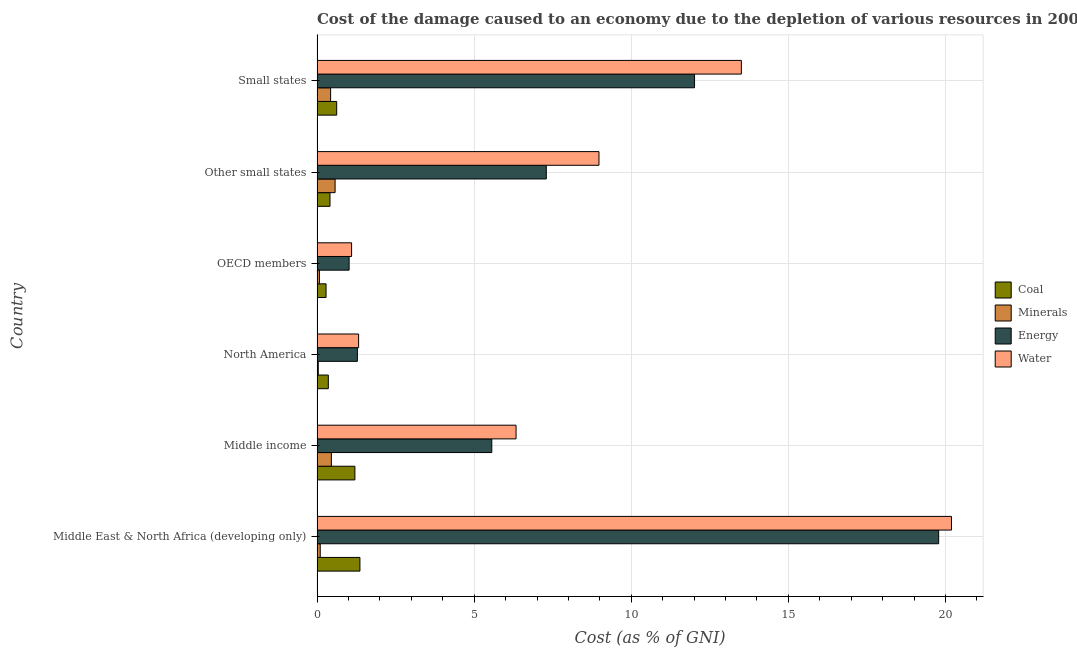Are the number of bars on each tick of the Y-axis equal?
Offer a very short reply. Yes. What is the label of the 2nd group of bars from the top?
Make the answer very short. Other small states. In how many cases, is the number of bars for a given country not equal to the number of legend labels?
Your response must be concise. 0. What is the cost of damage due to depletion of coal in Middle income?
Offer a very short reply. 1.2. Across all countries, what is the maximum cost of damage due to depletion of coal?
Your answer should be very brief. 1.36. Across all countries, what is the minimum cost of damage due to depletion of coal?
Make the answer very short. 0.29. In which country was the cost of damage due to depletion of energy maximum?
Make the answer very short. Middle East & North Africa (developing only). In which country was the cost of damage due to depletion of coal minimum?
Your answer should be very brief. OECD members. What is the total cost of damage due to depletion of coal in the graph?
Keep it short and to the point. 4.25. What is the difference between the cost of damage due to depletion of minerals in Middle East & North Africa (developing only) and that in Small states?
Give a very brief answer. -0.33. What is the difference between the cost of damage due to depletion of minerals in Small states and the cost of damage due to depletion of energy in North America?
Offer a very short reply. -0.85. What is the average cost of damage due to depletion of coal per country?
Keep it short and to the point. 0.71. What is the difference between the cost of damage due to depletion of minerals and cost of damage due to depletion of coal in Other small states?
Your answer should be very brief. 0.16. What is the ratio of the cost of damage due to depletion of coal in OECD members to that in Other small states?
Make the answer very short. 0.69. What is the difference between the highest and the second highest cost of damage due to depletion of water?
Your answer should be compact. 6.69. What is the difference between the highest and the lowest cost of damage due to depletion of minerals?
Ensure brevity in your answer.  0.53. In how many countries, is the cost of damage due to depletion of coal greater than the average cost of damage due to depletion of coal taken over all countries?
Offer a very short reply. 2. Is the sum of the cost of damage due to depletion of energy in North America and Other small states greater than the maximum cost of damage due to depletion of coal across all countries?
Provide a succinct answer. Yes. Is it the case that in every country, the sum of the cost of damage due to depletion of minerals and cost of damage due to depletion of energy is greater than the sum of cost of damage due to depletion of water and cost of damage due to depletion of coal?
Your answer should be very brief. No. What does the 4th bar from the top in Middle income represents?
Offer a terse response. Coal. What does the 1st bar from the bottom in OECD members represents?
Offer a terse response. Coal. How many bars are there?
Your answer should be very brief. 24. What is the difference between two consecutive major ticks on the X-axis?
Your answer should be compact. 5. Does the graph contain grids?
Offer a terse response. Yes. Where does the legend appear in the graph?
Give a very brief answer. Center right. How many legend labels are there?
Your answer should be very brief. 4. What is the title of the graph?
Offer a terse response. Cost of the damage caused to an economy due to the depletion of various resources in 2005 . What is the label or title of the X-axis?
Keep it short and to the point. Cost (as % of GNI). What is the Cost (as % of GNI) of Coal in Middle East & North Africa (developing only)?
Your answer should be very brief. 1.36. What is the Cost (as % of GNI) in Minerals in Middle East & North Africa (developing only)?
Your answer should be compact. 0.1. What is the Cost (as % of GNI) of Energy in Middle East & North Africa (developing only)?
Give a very brief answer. 19.78. What is the Cost (as % of GNI) of Water in Middle East & North Africa (developing only)?
Provide a short and direct response. 20.19. What is the Cost (as % of GNI) in Coal in Middle income?
Provide a short and direct response. 1.2. What is the Cost (as % of GNI) in Minerals in Middle income?
Make the answer very short. 0.46. What is the Cost (as % of GNI) of Energy in Middle income?
Offer a very short reply. 5.56. What is the Cost (as % of GNI) in Water in Middle income?
Your answer should be very brief. 6.33. What is the Cost (as % of GNI) in Coal in North America?
Provide a succinct answer. 0.36. What is the Cost (as % of GNI) in Minerals in North America?
Keep it short and to the point. 0.04. What is the Cost (as % of GNI) of Energy in North America?
Give a very brief answer. 1.28. What is the Cost (as % of GNI) in Water in North America?
Provide a succinct answer. 1.32. What is the Cost (as % of GNI) of Coal in OECD members?
Your answer should be very brief. 0.29. What is the Cost (as % of GNI) of Minerals in OECD members?
Ensure brevity in your answer.  0.08. What is the Cost (as % of GNI) of Energy in OECD members?
Offer a very short reply. 1.02. What is the Cost (as % of GNI) in Water in OECD members?
Offer a terse response. 1.1. What is the Cost (as % of GNI) of Coal in Other small states?
Your answer should be compact. 0.41. What is the Cost (as % of GNI) of Minerals in Other small states?
Keep it short and to the point. 0.57. What is the Cost (as % of GNI) in Energy in Other small states?
Make the answer very short. 7.3. What is the Cost (as % of GNI) in Water in Other small states?
Make the answer very short. 8.97. What is the Cost (as % of GNI) in Coal in Small states?
Make the answer very short. 0.63. What is the Cost (as % of GNI) of Minerals in Small states?
Ensure brevity in your answer.  0.43. What is the Cost (as % of GNI) in Energy in Small states?
Offer a very short reply. 12.01. What is the Cost (as % of GNI) in Water in Small states?
Provide a succinct answer. 13.5. Across all countries, what is the maximum Cost (as % of GNI) of Coal?
Your response must be concise. 1.36. Across all countries, what is the maximum Cost (as % of GNI) in Minerals?
Provide a short and direct response. 0.57. Across all countries, what is the maximum Cost (as % of GNI) in Energy?
Provide a succinct answer. 19.78. Across all countries, what is the maximum Cost (as % of GNI) of Water?
Keep it short and to the point. 20.19. Across all countries, what is the minimum Cost (as % of GNI) in Coal?
Keep it short and to the point. 0.29. Across all countries, what is the minimum Cost (as % of GNI) in Minerals?
Your answer should be very brief. 0.04. Across all countries, what is the minimum Cost (as % of GNI) of Energy?
Offer a terse response. 1.02. Across all countries, what is the minimum Cost (as % of GNI) in Water?
Your answer should be compact. 1.1. What is the total Cost (as % of GNI) of Coal in the graph?
Your response must be concise. 4.25. What is the total Cost (as % of GNI) of Minerals in the graph?
Offer a terse response. 1.68. What is the total Cost (as % of GNI) of Energy in the graph?
Make the answer very short. 46.96. What is the total Cost (as % of GNI) in Water in the graph?
Provide a short and direct response. 51.42. What is the difference between the Cost (as % of GNI) of Coal in Middle East & North Africa (developing only) and that in Middle income?
Your response must be concise. 0.16. What is the difference between the Cost (as % of GNI) in Minerals in Middle East & North Africa (developing only) and that in Middle income?
Make the answer very short. -0.35. What is the difference between the Cost (as % of GNI) in Energy in Middle East & North Africa (developing only) and that in Middle income?
Give a very brief answer. 14.22. What is the difference between the Cost (as % of GNI) of Water in Middle East & North Africa (developing only) and that in Middle income?
Provide a short and direct response. 13.86. What is the difference between the Cost (as % of GNI) of Coal in Middle East & North Africa (developing only) and that in North America?
Provide a succinct answer. 1.01. What is the difference between the Cost (as % of GNI) in Minerals in Middle East & North Africa (developing only) and that in North America?
Offer a very short reply. 0.06. What is the difference between the Cost (as % of GNI) in Energy in Middle East & North Africa (developing only) and that in North America?
Your answer should be compact. 18.5. What is the difference between the Cost (as % of GNI) in Water in Middle East & North Africa (developing only) and that in North America?
Provide a short and direct response. 18.87. What is the difference between the Cost (as % of GNI) in Coal in Middle East & North Africa (developing only) and that in OECD members?
Keep it short and to the point. 1.08. What is the difference between the Cost (as % of GNI) of Minerals in Middle East & North Africa (developing only) and that in OECD members?
Keep it short and to the point. 0.03. What is the difference between the Cost (as % of GNI) of Energy in Middle East & North Africa (developing only) and that in OECD members?
Your answer should be very brief. 18.76. What is the difference between the Cost (as % of GNI) of Water in Middle East & North Africa (developing only) and that in OECD members?
Your answer should be compact. 19.09. What is the difference between the Cost (as % of GNI) in Coal in Middle East & North Africa (developing only) and that in Other small states?
Keep it short and to the point. 0.95. What is the difference between the Cost (as % of GNI) in Minerals in Middle East & North Africa (developing only) and that in Other small states?
Provide a short and direct response. -0.47. What is the difference between the Cost (as % of GNI) in Energy in Middle East & North Africa (developing only) and that in Other small states?
Make the answer very short. 12.49. What is the difference between the Cost (as % of GNI) in Water in Middle East & North Africa (developing only) and that in Other small states?
Your response must be concise. 11.22. What is the difference between the Cost (as % of GNI) of Coal in Middle East & North Africa (developing only) and that in Small states?
Your answer should be compact. 0.74. What is the difference between the Cost (as % of GNI) in Minerals in Middle East & North Africa (developing only) and that in Small states?
Make the answer very short. -0.33. What is the difference between the Cost (as % of GNI) of Energy in Middle East & North Africa (developing only) and that in Small states?
Provide a short and direct response. 7.77. What is the difference between the Cost (as % of GNI) of Water in Middle East & North Africa (developing only) and that in Small states?
Give a very brief answer. 6.69. What is the difference between the Cost (as % of GNI) in Coal in Middle income and that in North America?
Your answer should be very brief. 0.85. What is the difference between the Cost (as % of GNI) of Minerals in Middle income and that in North America?
Your response must be concise. 0.42. What is the difference between the Cost (as % of GNI) in Energy in Middle income and that in North America?
Provide a short and direct response. 4.28. What is the difference between the Cost (as % of GNI) of Water in Middle income and that in North America?
Offer a very short reply. 5.01. What is the difference between the Cost (as % of GNI) in Coal in Middle income and that in OECD members?
Make the answer very short. 0.92. What is the difference between the Cost (as % of GNI) in Minerals in Middle income and that in OECD members?
Keep it short and to the point. 0.38. What is the difference between the Cost (as % of GNI) in Energy in Middle income and that in OECD members?
Give a very brief answer. 4.54. What is the difference between the Cost (as % of GNI) of Water in Middle income and that in OECD members?
Offer a terse response. 5.23. What is the difference between the Cost (as % of GNI) of Coal in Middle income and that in Other small states?
Offer a terse response. 0.79. What is the difference between the Cost (as % of GNI) in Minerals in Middle income and that in Other small states?
Provide a succinct answer. -0.12. What is the difference between the Cost (as % of GNI) of Energy in Middle income and that in Other small states?
Your answer should be compact. -1.74. What is the difference between the Cost (as % of GNI) of Water in Middle income and that in Other small states?
Provide a short and direct response. -2.64. What is the difference between the Cost (as % of GNI) of Coal in Middle income and that in Small states?
Your answer should be compact. 0.58. What is the difference between the Cost (as % of GNI) in Minerals in Middle income and that in Small states?
Your answer should be compact. 0.02. What is the difference between the Cost (as % of GNI) in Energy in Middle income and that in Small states?
Offer a terse response. -6.45. What is the difference between the Cost (as % of GNI) in Water in Middle income and that in Small states?
Offer a very short reply. -7.17. What is the difference between the Cost (as % of GNI) of Coal in North America and that in OECD members?
Make the answer very short. 0.07. What is the difference between the Cost (as % of GNI) of Minerals in North America and that in OECD members?
Provide a short and direct response. -0.04. What is the difference between the Cost (as % of GNI) of Energy in North America and that in OECD members?
Your answer should be very brief. 0.26. What is the difference between the Cost (as % of GNI) in Water in North America and that in OECD members?
Give a very brief answer. 0.22. What is the difference between the Cost (as % of GNI) of Coal in North America and that in Other small states?
Provide a short and direct response. -0.05. What is the difference between the Cost (as % of GNI) in Minerals in North America and that in Other small states?
Keep it short and to the point. -0.54. What is the difference between the Cost (as % of GNI) in Energy in North America and that in Other small states?
Your answer should be very brief. -6.01. What is the difference between the Cost (as % of GNI) of Water in North America and that in Other small states?
Your answer should be compact. -7.65. What is the difference between the Cost (as % of GNI) of Coal in North America and that in Small states?
Provide a short and direct response. -0.27. What is the difference between the Cost (as % of GNI) in Minerals in North America and that in Small states?
Keep it short and to the point. -0.39. What is the difference between the Cost (as % of GNI) in Energy in North America and that in Small states?
Offer a terse response. -10.73. What is the difference between the Cost (as % of GNI) in Water in North America and that in Small states?
Ensure brevity in your answer.  -12.18. What is the difference between the Cost (as % of GNI) of Coal in OECD members and that in Other small states?
Ensure brevity in your answer.  -0.13. What is the difference between the Cost (as % of GNI) of Minerals in OECD members and that in Other small states?
Your answer should be compact. -0.5. What is the difference between the Cost (as % of GNI) in Energy in OECD members and that in Other small states?
Offer a very short reply. -6.28. What is the difference between the Cost (as % of GNI) of Water in OECD members and that in Other small states?
Make the answer very short. -7.87. What is the difference between the Cost (as % of GNI) in Coal in OECD members and that in Small states?
Offer a terse response. -0.34. What is the difference between the Cost (as % of GNI) in Minerals in OECD members and that in Small states?
Keep it short and to the point. -0.36. What is the difference between the Cost (as % of GNI) in Energy in OECD members and that in Small states?
Ensure brevity in your answer.  -10.99. What is the difference between the Cost (as % of GNI) in Water in OECD members and that in Small states?
Offer a terse response. -12.4. What is the difference between the Cost (as % of GNI) in Coal in Other small states and that in Small states?
Offer a very short reply. -0.21. What is the difference between the Cost (as % of GNI) of Minerals in Other small states and that in Small states?
Ensure brevity in your answer.  0.14. What is the difference between the Cost (as % of GNI) of Energy in Other small states and that in Small states?
Ensure brevity in your answer.  -4.72. What is the difference between the Cost (as % of GNI) in Water in Other small states and that in Small states?
Offer a terse response. -4.53. What is the difference between the Cost (as % of GNI) in Coal in Middle East & North Africa (developing only) and the Cost (as % of GNI) in Minerals in Middle income?
Keep it short and to the point. 0.91. What is the difference between the Cost (as % of GNI) of Coal in Middle East & North Africa (developing only) and the Cost (as % of GNI) of Energy in Middle income?
Provide a short and direct response. -4.2. What is the difference between the Cost (as % of GNI) in Coal in Middle East & North Africa (developing only) and the Cost (as % of GNI) in Water in Middle income?
Make the answer very short. -4.97. What is the difference between the Cost (as % of GNI) in Minerals in Middle East & North Africa (developing only) and the Cost (as % of GNI) in Energy in Middle income?
Give a very brief answer. -5.46. What is the difference between the Cost (as % of GNI) of Minerals in Middle East & North Africa (developing only) and the Cost (as % of GNI) of Water in Middle income?
Your answer should be very brief. -6.23. What is the difference between the Cost (as % of GNI) in Energy in Middle East & North Africa (developing only) and the Cost (as % of GNI) in Water in Middle income?
Your answer should be very brief. 13.45. What is the difference between the Cost (as % of GNI) of Coal in Middle East & North Africa (developing only) and the Cost (as % of GNI) of Minerals in North America?
Ensure brevity in your answer.  1.33. What is the difference between the Cost (as % of GNI) of Coal in Middle East & North Africa (developing only) and the Cost (as % of GNI) of Energy in North America?
Your answer should be very brief. 0.08. What is the difference between the Cost (as % of GNI) of Coal in Middle East & North Africa (developing only) and the Cost (as % of GNI) of Water in North America?
Keep it short and to the point. 0.04. What is the difference between the Cost (as % of GNI) in Minerals in Middle East & North Africa (developing only) and the Cost (as % of GNI) in Energy in North America?
Your response must be concise. -1.18. What is the difference between the Cost (as % of GNI) in Minerals in Middle East & North Africa (developing only) and the Cost (as % of GNI) in Water in North America?
Your answer should be compact. -1.22. What is the difference between the Cost (as % of GNI) in Energy in Middle East & North Africa (developing only) and the Cost (as % of GNI) in Water in North America?
Keep it short and to the point. 18.46. What is the difference between the Cost (as % of GNI) of Coal in Middle East & North Africa (developing only) and the Cost (as % of GNI) of Minerals in OECD members?
Offer a very short reply. 1.29. What is the difference between the Cost (as % of GNI) in Coal in Middle East & North Africa (developing only) and the Cost (as % of GNI) in Energy in OECD members?
Ensure brevity in your answer.  0.34. What is the difference between the Cost (as % of GNI) in Coal in Middle East & North Africa (developing only) and the Cost (as % of GNI) in Water in OECD members?
Your answer should be very brief. 0.27. What is the difference between the Cost (as % of GNI) in Minerals in Middle East & North Africa (developing only) and the Cost (as % of GNI) in Energy in OECD members?
Offer a very short reply. -0.92. What is the difference between the Cost (as % of GNI) in Minerals in Middle East & North Africa (developing only) and the Cost (as % of GNI) in Water in OECD members?
Your response must be concise. -1. What is the difference between the Cost (as % of GNI) in Energy in Middle East & North Africa (developing only) and the Cost (as % of GNI) in Water in OECD members?
Your answer should be very brief. 18.68. What is the difference between the Cost (as % of GNI) in Coal in Middle East & North Africa (developing only) and the Cost (as % of GNI) in Minerals in Other small states?
Give a very brief answer. 0.79. What is the difference between the Cost (as % of GNI) in Coal in Middle East & North Africa (developing only) and the Cost (as % of GNI) in Energy in Other small states?
Your answer should be compact. -5.93. What is the difference between the Cost (as % of GNI) in Coal in Middle East & North Africa (developing only) and the Cost (as % of GNI) in Water in Other small states?
Offer a very short reply. -7.61. What is the difference between the Cost (as % of GNI) of Minerals in Middle East & North Africa (developing only) and the Cost (as % of GNI) of Energy in Other small states?
Provide a succinct answer. -7.19. What is the difference between the Cost (as % of GNI) in Minerals in Middle East & North Africa (developing only) and the Cost (as % of GNI) in Water in Other small states?
Make the answer very short. -8.87. What is the difference between the Cost (as % of GNI) of Energy in Middle East & North Africa (developing only) and the Cost (as % of GNI) of Water in Other small states?
Ensure brevity in your answer.  10.81. What is the difference between the Cost (as % of GNI) of Coal in Middle East & North Africa (developing only) and the Cost (as % of GNI) of Minerals in Small states?
Your response must be concise. 0.93. What is the difference between the Cost (as % of GNI) in Coal in Middle East & North Africa (developing only) and the Cost (as % of GNI) in Energy in Small states?
Give a very brief answer. -10.65. What is the difference between the Cost (as % of GNI) of Coal in Middle East & North Africa (developing only) and the Cost (as % of GNI) of Water in Small states?
Provide a short and direct response. -12.14. What is the difference between the Cost (as % of GNI) of Minerals in Middle East & North Africa (developing only) and the Cost (as % of GNI) of Energy in Small states?
Offer a terse response. -11.91. What is the difference between the Cost (as % of GNI) of Minerals in Middle East & North Africa (developing only) and the Cost (as % of GNI) of Water in Small states?
Ensure brevity in your answer.  -13.4. What is the difference between the Cost (as % of GNI) in Energy in Middle East & North Africa (developing only) and the Cost (as % of GNI) in Water in Small states?
Offer a very short reply. 6.28. What is the difference between the Cost (as % of GNI) of Coal in Middle income and the Cost (as % of GNI) of Minerals in North America?
Provide a short and direct response. 1.17. What is the difference between the Cost (as % of GNI) of Coal in Middle income and the Cost (as % of GNI) of Energy in North America?
Keep it short and to the point. -0.08. What is the difference between the Cost (as % of GNI) of Coal in Middle income and the Cost (as % of GNI) of Water in North America?
Ensure brevity in your answer.  -0.12. What is the difference between the Cost (as % of GNI) of Minerals in Middle income and the Cost (as % of GNI) of Energy in North America?
Keep it short and to the point. -0.83. What is the difference between the Cost (as % of GNI) in Minerals in Middle income and the Cost (as % of GNI) in Water in North America?
Provide a short and direct response. -0.87. What is the difference between the Cost (as % of GNI) in Energy in Middle income and the Cost (as % of GNI) in Water in North America?
Keep it short and to the point. 4.24. What is the difference between the Cost (as % of GNI) of Coal in Middle income and the Cost (as % of GNI) of Minerals in OECD members?
Offer a terse response. 1.13. What is the difference between the Cost (as % of GNI) in Coal in Middle income and the Cost (as % of GNI) in Energy in OECD members?
Provide a short and direct response. 0.18. What is the difference between the Cost (as % of GNI) in Coal in Middle income and the Cost (as % of GNI) in Water in OECD members?
Your answer should be very brief. 0.1. What is the difference between the Cost (as % of GNI) of Minerals in Middle income and the Cost (as % of GNI) of Energy in OECD members?
Your response must be concise. -0.56. What is the difference between the Cost (as % of GNI) of Minerals in Middle income and the Cost (as % of GNI) of Water in OECD members?
Your answer should be very brief. -0.64. What is the difference between the Cost (as % of GNI) in Energy in Middle income and the Cost (as % of GNI) in Water in OECD members?
Offer a terse response. 4.46. What is the difference between the Cost (as % of GNI) in Coal in Middle income and the Cost (as % of GNI) in Minerals in Other small states?
Keep it short and to the point. 0.63. What is the difference between the Cost (as % of GNI) in Coal in Middle income and the Cost (as % of GNI) in Energy in Other small states?
Keep it short and to the point. -6.09. What is the difference between the Cost (as % of GNI) in Coal in Middle income and the Cost (as % of GNI) in Water in Other small states?
Your answer should be very brief. -7.77. What is the difference between the Cost (as % of GNI) of Minerals in Middle income and the Cost (as % of GNI) of Energy in Other small states?
Keep it short and to the point. -6.84. What is the difference between the Cost (as % of GNI) in Minerals in Middle income and the Cost (as % of GNI) in Water in Other small states?
Your answer should be very brief. -8.52. What is the difference between the Cost (as % of GNI) of Energy in Middle income and the Cost (as % of GNI) of Water in Other small states?
Your response must be concise. -3.41. What is the difference between the Cost (as % of GNI) of Coal in Middle income and the Cost (as % of GNI) of Minerals in Small states?
Offer a very short reply. 0.77. What is the difference between the Cost (as % of GNI) in Coal in Middle income and the Cost (as % of GNI) in Energy in Small states?
Your answer should be compact. -10.81. What is the difference between the Cost (as % of GNI) in Coal in Middle income and the Cost (as % of GNI) in Water in Small states?
Keep it short and to the point. -12.3. What is the difference between the Cost (as % of GNI) of Minerals in Middle income and the Cost (as % of GNI) of Energy in Small states?
Your response must be concise. -11.56. What is the difference between the Cost (as % of GNI) in Minerals in Middle income and the Cost (as % of GNI) in Water in Small states?
Provide a short and direct response. -13.05. What is the difference between the Cost (as % of GNI) in Energy in Middle income and the Cost (as % of GNI) in Water in Small states?
Your response must be concise. -7.94. What is the difference between the Cost (as % of GNI) in Coal in North America and the Cost (as % of GNI) in Minerals in OECD members?
Give a very brief answer. 0.28. What is the difference between the Cost (as % of GNI) of Coal in North America and the Cost (as % of GNI) of Energy in OECD members?
Keep it short and to the point. -0.66. What is the difference between the Cost (as % of GNI) in Coal in North America and the Cost (as % of GNI) in Water in OECD members?
Make the answer very short. -0.74. What is the difference between the Cost (as % of GNI) in Minerals in North America and the Cost (as % of GNI) in Energy in OECD members?
Offer a terse response. -0.98. What is the difference between the Cost (as % of GNI) of Minerals in North America and the Cost (as % of GNI) of Water in OECD members?
Your answer should be very brief. -1.06. What is the difference between the Cost (as % of GNI) of Energy in North America and the Cost (as % of GNI) of Water in OECD members?
Make the answer very short. 0.18. What is the difference between the Cost (as % of GNI) in Coal in North America and the Cost (as % of GNI) in Minerals in Other small states?
Your answer should be very brief. -0.22. What is the difference between the Cost (as % of GNI) of Coal in North America and the Cost (as % of GNI) of Energy in Other small states?
Give a very brief answer. -6.94. What is the difference between the Cost (as % of GNI) in Coal in North America and the Cost (as % of GNI) in Water in Other small states?
Make the answer very short. -8.61. What is the difference between the Cost (as % of GNI) of Minerals in North America and the Cost (as % of GNI) of Energy in Other small states?
Your answer should be very brief. -7.26. What is the difference between the Cost (as % of GNI) in Minerals in North America and the Cost (as % of GNI) in Water in Other small states?
Your answer should be compact. -8.93. What is the difference between the Cost (as % of GNI) of Energy in North America and the Cost (as % of GNI) of Water in Other small states?
Offer a very short reply. -7.69. What is the difference between the Cost (as % of GNI) of Coal in North America and the Cost (as % of GNI) of Minerals in Small states?
Ensure brevity in your answer.  -0.07. What is the difference between the Cost (as % of GNI) of Coal in North America and the Cost (as % of GNI) of Energy in Small states?
Provide a short and direct response. -11.65. What is the difference between the Cost (as % of GNI) of Coal in North America and the Cost (as % of GNI) of Water in Small states?
Keep it short and to the point. -13.14. What is the difference between the Cost (as % of GNI) in Minerals in North America and the Cost (as % of GNI) in Energy in Small states?
Offer a very short reply. -11.97. What is the difference between the Cost (as % of GNI) of Minerals in North America and the Cost (as % of GNI) of Water in Small states?
Keep it short and to the point. -13.46. What is the difference between the Cost (as % of GNI) in Energy in North America and the Cost (as % of GNI) in Water in Small states?
Ensure brevity in your answer.  -12.22. What is the difference between the Cost (as % of GNI) in Coal in OECD members and the Cost (as % of GNI) in Minerals in Other small states?
Ensure brevity in your answer.  -0.29. What is the difference between the Cost (as % of GNI) of Coal in OECD members and the Cost (as % of GNI) of Energy in Other small states?
Provide a succinct answer. -7.01. What is the difference between the Cost (as % of GNI) of Coal in OECD members and the Cost (as % of GNI) of Water in Other small states?
Make the answer very short. -8.69. What is the difference between the Cost (as % of GNI) in Minerals in OECD members and the Cost (as % of GNI) in Energy in Other small states?
Offer a very short reply. -7.22. What is the difference between the Cost (as % of GNI) in Minerals in OECD members and the Cost (as % of GNI) in Water in Other small states?
Ensure brevity in your answer.  -8.9. What is the difference between the Cost (as % of GNI) of Energy in OECD members and the Cost (as % of GNI) of Water in Other small states?
Your answer should be very brief. -7.95. What is the difference between the Cost (as % of GNI) of Coal in OECD members and the Cost (as % of GNI) of Minerals in Small states?
Your answer should be very brief. -0.14. What is the difference between the Cost (as % of GNI) of Coal in OECD members and the Cost (as % of GNI) of Energy in Small states?
Provide a succinct answer. -11.73. What is the difference between the Cost (as % of GNI) in Coal in OECD members and the Cost (as % of GNI) in Water in Small states?
Keep it short and to the point. -13.22. What is the difference between the Cost (as % of GNI) of Minerals in OECD members and the Cost (as % of GNI) of Energy in Small states?
Ensure brevity in your answer.  -11.94. What is the difference between the Cost (as % of GNI) in Minerals in OECD members and the Cost (as % of GNI) in Water in Small states?
Offer a very short reply. -13.43. What is the difference between the Cost (as % of GNI) in Energy in OECD members and the Cost (as % of GNI) in Water in Small states?
Offer a very short reply. -12.48. What is the difference between the Cost (as % of GNI) in Coal in Other small states and the Cost (as % of GNI) in Minerals in Small states?
Ensure brevity in your answer.  -0.02. What is the difference between the Cost (as % of GNI) in Coal in Other small states and the Cost (as % of GNI) in Energy in Small states?
Give a very brief answer. -11.6. What is the difference between the Cost (as % of GNI) of Coal in Other small states and the Cost (as % of GNI) of Water in Small states?
Offer a terse response. -13.09. What is the difference between the Cost (as % of GNI) of Minerals in Other small states and the Cost (as % of GNI) of Energy in Small states?
Your answer should be very brief. -11.44. What is the difference between the Cost (as % of GNI) in Minerals in Other small states and the Cost (as % of GNI) in Water in Small states?
Provide a succinct answer. -12.93. What is the difference between the Cost (as % of GNI) of Energy in Other small states and the Cost (as % of GNI) of Water in Small states?
Offer a terse response. -6.21. What is the average Cost (as % of GNI) of Coal per country?
Your response must be concise. 0.71. What is the average Cost (as % of GNI) of Minerals per country?
Make the answer very short. 0.28. What is the average Cost (as % of GNI) in Energy per country?
Offer a very short reply. 7.83. What is the average Cost (as % of GNI) of Water per country?
Keep it short and to the point. 8.57. What is the difference between the Cost (as % of GNI) in Coal and Cost (as % of GNI) in Minerals in Middle East & North Africa (developing only)?
Your answer should be compact. 1.26. What is the difference between the Cost (as % of GNI) in Coal and Cost (as % of GNI) in Energy in Middle East & North Africa (developing only)?
Offer a terse response. -18.42. What is the difference between the Cost (as % of GNI) of Coal and Cost (as % of GNI) of Water in Middle East & North Africa (developing only)?
Your response must be concise. -18.83. What is the difference between the Cost (as % of GNI) in Minerals and Cost (as % of GNI) in Energy in Middle East & North Africa (developing only)?
Provide a short and direct response. -19.68. What is the difference between the Cost (as % of GNI) in Minerals and Cost (as % of GNI) in Water in Middle East & North Africa (developing only)?
Offer a terse response. -20.09. What is the difference between the Cost (as % of GNI) in Energy and Cost (as % of GNI) in Water in Middle East & North Africa (developing only)?
Ensure brevity in your answer.  -0.41. What is the difference between the Cost (as % of GNI) of Coal and Cost (as % of GNI) of Minerals in Middle income?
Make the answer very short. 0.75. What is the difference between the Cost (as % of GNI) in Coal and Cost (as % of GNI) in Energy in Middle income?
Provide a short and direct response. -4.36. What is the difference between the Cost (as % of GNI) of Coal and Cost (as % of GNI) of Water in Middle income?
Your answer should be compact. -5.13. What is the difference between the Cost (as % of GNI) in Minerals and Cost (as % of GNI) in Energy in Middle income?
Offer a terse response. -5.11. What is the difference between the Cost (as % of GNI) in Minerals and Cost (as % of GNI) in Water in Middle income?
Provide a short and direct response. -5.88. What is the difference between the Cost (as % of GNI) in Energy and Cost (as % of GNI) in Water in Middle income?
Give a very brief answer. -0.77. What is the difference between the Cost (as % of GNI) in Coal and Cost (as % of GNI) in Minerals in North America?
Offer a terse response. 0.32. What is the difference between the Cost (as % of GNI) of Coal and Cost (as % of GNI) of Energy in North America?
Your answer should be compact. -0.92. What is the difference between the Cost (as % of GNI) of Coal and Cost (as % of GNI) of Water in North America?
Your answer should be compact. -0.96. What is the difference between the Cost (as % of GNI) in Minerals and Cost (as % of GNI) in Energy in North America?
Make the answer very short. -1.24. What is the difference between the Cost (as % of GNI) in Minerals and Cost (as % of GNI) in Water in North America?
Provide a short and direct response. -1.28. What is the difference between the Cost (as % of GNI) of Energy and Cost (as % of GNI) of Water in North America?
Provide a succinct answer. -0.04. What is the difference between the Cost (as % of GNI) in Coal and Cost (as % of GNI) in Minerals in OECD members?
Offer a terse response. 0.21. What is the difference between the Cost (as % of GNI) in Coal and Cost (as % of GNI) in Energy in OECD members?
Your answer should be very brief. -0.73. What is the difference between the Cost (as % of GNI) in Coal and Cost (as % of GNI) in Water in OECD members?
Provide a succinct answer. -0.81. What is the difference between the Cost (as % of GNI) of Minerals and Cost (as % of GNI) of Energy in OECD members?
Offer a terse response. -0.94. What is the difference between the Cost (as % of GNI) in Minerals and Cost (as % of GNI) in Water in OECD members?
Make the answer very short. -1.02. What is the difference between the Cost (as % of GNI) of Energy and Cost (as % of GNI) of Water in OECD members?
Keep it short and to the point. -0.08. What is the difference between the Cost (as % of GNI) in Coal and Cost (as % of GNI) in Minerals in Other small states?
Your answer should be compact. -0.16. What is the difference between the Cost (as % of GNI) in Coal and Cost (as % of GNI) in Energy in Other small states?
Offer a very short reply. -6.88. What is the difference between the Cost (as % of GNI) of Coal and Cost (as % of GNI) of Water in Other small states?
Keep it short and to the point. -8.56. What is the difference between the Cost (as % of GNI) in Minerals and Cost (as % of GNI) in Energy in Other small states?
Offer a very short reply. -6.72. What is the difference between the Cost (as % of GNI) in Minerals and Cost (as % of GNI) in Water in Other small states?
Provide a succinct answer. -8.4. What is the difference between the Cost (as % of GNI) in Energy and Cost (as % of GNI) in Water in Other small states?
Your answer should be very brief. -1.68. What is the difference between the Cost (as % of GNI) in Coal and Cost (as % of GNI) in Minerals in Small states?
Keep it short and to the point. 0.19. What is the difference between the Cost (as % of GNI) of Coal and Cost (as % of GNI) of Energy in Small states?
Ensure brevity in your answer.  -11.39. What is the difference between the Cost (as % of GNI) in Coal and Cost (as % of GNI) in Water in Small states?
Your response must be concise. -12.88. What is the difference between the Cost (as % of GNI) of Minerals and Cost (as % of GNI) of Energy in Small states?
Keep it short and to the point. -11.58. What is the difference between the Cost (as % of GNI) in Minerals and Cost (as % of GNI) in Water in Small states?
Ensure brevity in your answer.  -13.07. What is the difference between the Cost (as % of GNI) in Energy and Cost (as % of GNI) in Water in Small states?
Offer a very short reply. -1.49. What is the ratio of the Cost (as % of GNI) in Coal in Middle East & North Africa (developing only) to that in Middle income?
Keep it short and to the point. 1.13. What is the ratio of the Cost (as % of GNI) in Minerals in Middle East & North Africa (developing only) to that in Middle income?
Ensure brevity in your answer.  0.22. What is the ratio of the Cost (as % of GNI) of Energy in Middle East & North Africa (developing only) to that in Middle income?
Offer a terse response. 3.56. What is the ratio of the Cost (as % of GNI) in Water in Middle East & North Africa (developing only) to that in Middle income?
Keep it short and to the point. 3.19. What is the ratio of the Cost (as % of GNI) in Coal in Middle East & North Africa (developing only) to that in North America?
Provide a succinct answer. 3.8. What is the ratio of the Cost (as % of GNI) of Minerals in Middle East & North Africa (developing only) to that in North America?
Give a very brief answer. 2.58. What is the ratio of the Cost (as % of GNI) of Energy in Middle East & North Africa (developing only) to that in North America?
Ensure brevity in your answer.  15.42. What is the ratio of the Cost (as % of GNI) of Water in Middle East & North Africa (developing only) to that in North America?
Your response must be concise. 15.27. What is the ratio of the Cost (as % of GNI) of Coal in Middle East & North Africa (developing only) to that in OECD members?
Keep it short and to the point. 4.76. What is the ratio of the Cost (as % of GNI) of Minerals in Middle East & North Africa (developing only) to that in OECD members?
Keep it short and to the point. 1.35. What is the ratio of the Cost (as % of GNI) of Energy in Middle East & North Africa (developing only) to that in OECD members?
Offer a very short reply. 19.39. What is the ratio of the Cost (as % of GNI) of Water in Middle East & North Africa (developing only) to that in OECD members?
Offer a terse response. 18.37. What is the ratio of the Cost (as % of GNI) in Coal in Middle East & North Africa (developing only) to that in Other small states?
Give a very brief answer. 3.31. What is the ratio of the Cost (as % of GNI) of Minerals in Middle East & North Africa (developing only) to that in Other small states?
Offer a very short reply. 0.18. What is the ratio of the Cost (as % of GNI) in Energy in Middle East & North Africa (developing only) to that in Other small states?
Ensure brevity in your answer.  2.71. What is the ratio of the Cost (as % of GNI) of Water in Middle East & North Africa (developing only) to that in Other small states?
Provide a short and direct response. 2.25. What is the ratio of the Cost (as % of GNI) in Coal in Middle East & North Africa (developing only) to that in Small states?
Your response must be concise. 2.18. What is the ratio of the Cost (as % of GNI) of Minerals in Middle East & North Africa (developing only) to that in Small states?
Provide a short and direct response. 0.23. What is the ratio of the Cost (as % of GNI) in Energy in Middle East & North Africa (developing only) to that in Small states?
Your answer should be compact. 1.65. What is the ratio of the Cost (as % of GNI) in Water in Middle East & North Africa (developing only) to that in Small states?
Provide a short and direct response. 1.5. What is the ratio of the Cost (as % of GNI) of Coal in Middle income to that in North America?
Ensure brevity in your answer.  3.36. What is the ratio of the Cost (as % of GNI) of Minerals in Middle income to that in North America?
Your answer should be very brief. 11.61. What is the ratio of the Cost (as % of GNI) in Energy in Middle income to that in North America?
Offer a terse response. 4.33. What is the ratio of the Cost (as % of GNI) in Water in Middle income to that in North America?
Give a very brief answer. 4.79. What is the ratio of the Cost (as % of GNI) in Coal in Middle income to that in OECD members?
Keep it short and to the point. 4.2. What is the ratio of the Cost (as % of GNI) in Minerals in Middle income to that in OECD members?
Provide a short and direct response. 6.07. What is the ratio of the Cost (as % of GNI) of Energy in Middle income to that in OECD members?
Your answer should be compact. 5.45. What is the ratio of the Cost (as % of GNI) of Water in Middle income to that in OECD members?
Offer a terse response. 5.76. What is the ratio of the Cost (as % of GNI) in Coal in Middle income to that in Other small states?
Offer a very short reply. 2.92. What is the ratio of the Cost (as % of GNI) in Minerals in Middle income to that in Other small states?
Provide a succinct answer. 0.79. What is the ratio of the Cost (as % of GNI) in Energy in Middle income to that in Other small states?
Give a very brief answer. 0.76. What is the ratio of the Cost (as % of GNI) of Water in Middle income to that in Other small states?
Your answer should be compact. 0.71. What is the ratio of the Cost (as % of GNI) in Coal in Middle income to that in Small states?
Provide a short and direct response. 1.93. What is the ratio of the Cost (as % of GNI) in Minerals in Middle income to that in Small states?
Your response must be concise. 1.06. What is the ratio of the Cost (as % of GNI) of Energy in Middle income to that in Small states?
Provide a short and direct response. 0.46. What is the ratio of the Cost (as % of GNI) in Water in Middle income to that in Small states?
Your response must be concise. 0.47. What is the ratio of the Cost (as % of GNI) of Coal in North America to that in OECD members?
Your response must be concise. 1.25. What is the ratio of the Cost (as % of GNI) of Minerals in North America to that in OECD members?
Ensure brevity in your answer.  0.52. What is the ratio of the Cost (as % of GNI) in Energy in North America to that in OECD members?
Offer a terse response. 1.26. What is the ratio of the Cost (as % of GNI) in Water in North America to that in OECD members?
Your answer should be very brief. 1.2. What is the ratio of the Cost (as % of GNI) of Coal in North America to that in Other small states?
Give a very brief answer. 0.87. What is the ratio of the Cost (as % of GNI) in Minerals in North America to that in Other small states?
Your response must be concise. 0.07. What is the ratio of the Cost (as % of GNI) of Energy in North America to that in Other small states?
Your answer should be compact. 0.18. What is the ratio of the Cost (as % of GNI) in Water in North America to that in Other small states?
Offer a very short reply. 0.15. What is the ratio of the Cost (as % of GNI) of Coal in North America to that in Small states?
Keep it short and to the point. 0.57. What is the ratio of the Cost (as % of GNI) in Minerals in North America to that in Small states?
Provide a succinct answer. 0.09. What is the ratio of the Cost (as % of GNI) in Energy in North America to that in Small states?
Offer a terse response. 0.11. What is the ratio of the Cost (as % of GNI) in Water in North America to that in Small states?
Your answer should be compact. 0.1. What is the ratio of the Cost (as % of GNI) of Coal in OECD members to that in Other small states?
Give a very brief answer. 0.7. What is the ratio of the Cost (as % of GNI) in Minerals in OECD members to that in Other small states?
Your answer should be very brief. 0.13. What is the ratio of the Cost (as % of GNI) of Energy in OECD members to that in Other small states?
Give a very brief answer. 0.14. What is the ratio of the Cost (as % of GNI) of Water in OECD members to that in Other small states?
Your answer should be compact. 0.12. What is the ratio of the Cost (as % of GNI) of Coal in OECD members to that in Small states?
Make the answer very short. 0.46. What is the ratio of the Cost (as % of GNI) in Minerals in OECD members to that in Small states?
Provide a short and direct response. 0.17. What is the ratio of the Cost (as % of GNI) of Energy in OECD members to that in Small states?
Your answer should be compact. 0.08. What is the ratio of the Cost (as % of GNI) in Water in OECD members to that in Small states?
Your answer should be compact. 0.08. What is the ratio of the Cost (as % of GNI) in Coal in Other small states to that in Small states?
Provide a succinct answer. 0.66. What is the ratio of the Cost (as % of GNI) of Minerals in Other small states to that in Small states?
Keep it short and to the point. 1.33. What is the ratio of the Cost (as % of GNI) in Energy in Other small states to that in Small states?
Your answer should be very brief. 0.61. What is the ratio of the Cost (as % of GNI) in Water in Other small states to that in Small states?
Offer a very short reply. 0.66. What is the difference between the highest and the second highest Cost (as % of GNI) of Coal?
Provide a short and direct response. 0.16. What is the difference between the highest and the second highest Cost (as % of GNI) of Minerals?
Your answer should be compact. 0.12. What is the difference between the highest and the second highest Cost (as % of GNI) in Energy?
Keep it short and to the point. 7.77. What is the difference between the highest and the second highest Cost (as % of GNI) of Water?
Offer a terse response. 6.69. What is the difference between the highest and the lowest Cost (as % of GNI) of Coal?
Offer a terse response. 1.08. What is the difference between the highest and the lowest Cost (as % of GNI) in Minerals?
Ensure brevity in your answer.  0.54. What is the difference between the highest and the lowest Cost (as % of GNI) in Energy?
Make the answer very short. 18.76. What is the difference between the highest and the lowest Cost (as % of GNI) in Water?
Offer a very short reply. 19.09. 